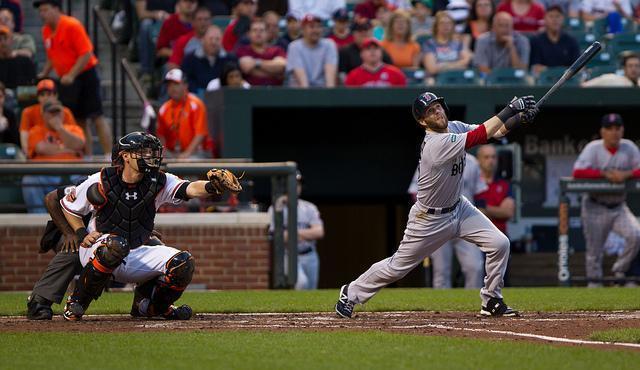How many people are there?
Give a very brief answer. 10. 